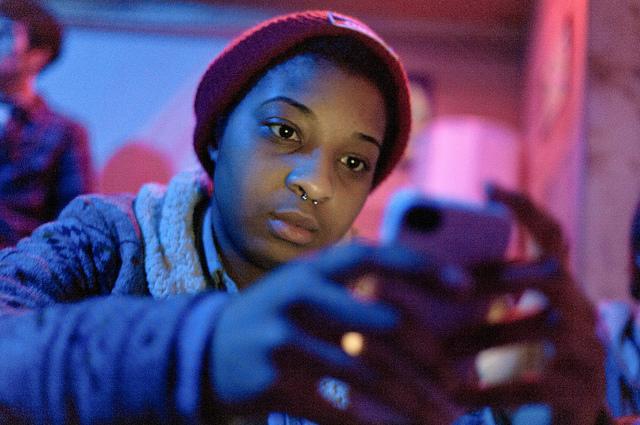What sport is he playing?
Short answer required. Phone. What is the design on her phone?
Concise answer only. None. Might one say that the real shot's been embedded into the background of the more obvious shot?
Be succinct. No. Is the person wearing a hat?
Keep it brief. Yes. What is the woman looking at?
Write a very short answer. Phone. What piercing is on this person's face?
Answer briefly. Nose. What kind of jacket does she have?
Answer briefly. Jean. What is the person wearing on her face?
Keep it brief. Nose ring. What is on the wall behind her?
Write a very short answer. Paint. 